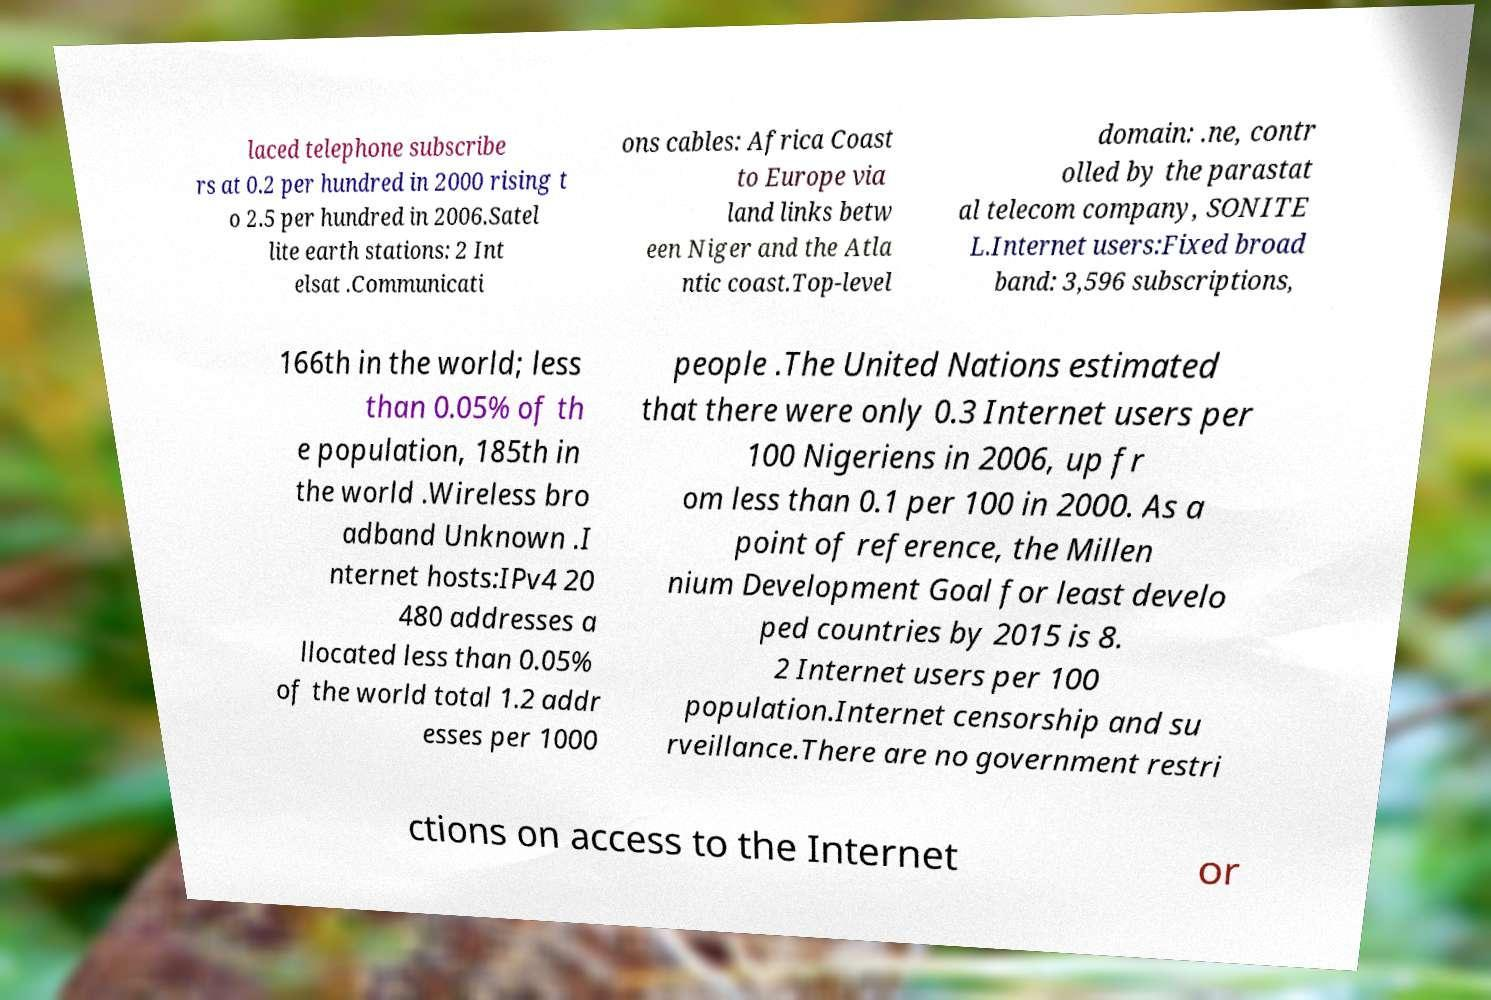There's text embedded in this image that I need extracted. Can you transcribe it verbatim? laced telephone subscribe rs at 0.2 per hundred in 2000 rising t o 2.5 per hundred in 2006.Satel lite earth stations: 2 Int elsat .Communicati ons cables: Africa Coast to Europe via land links betw een Niger and the Atla ntic coast.Top-level domain: .ne, contr olled by the parastat al telecom company, SONITE L.Internet users:Fixed broad band: 3,596 subscriptions, 166th in the world; less than 0.05% of th e population, 185th in the world .Wireless bro adband Unknown .I nternet hosts:IPv4 20 480 addresses a llocated less than 0.05% of the world total 1.2 addr esses per 1000 people .The United Nations estimated that there were only 0.3 Internet users per 100 Nigeriens in 2006, up fr om less than 0.1 per 100 in 2000. As a point of reference, the Millen nium Development Goal for least develo ped countries by 2015 is 8. 2 Internet users per 100 population.Internet censorship and su rveillance.There are no government restri ctions on access to the Internet or 